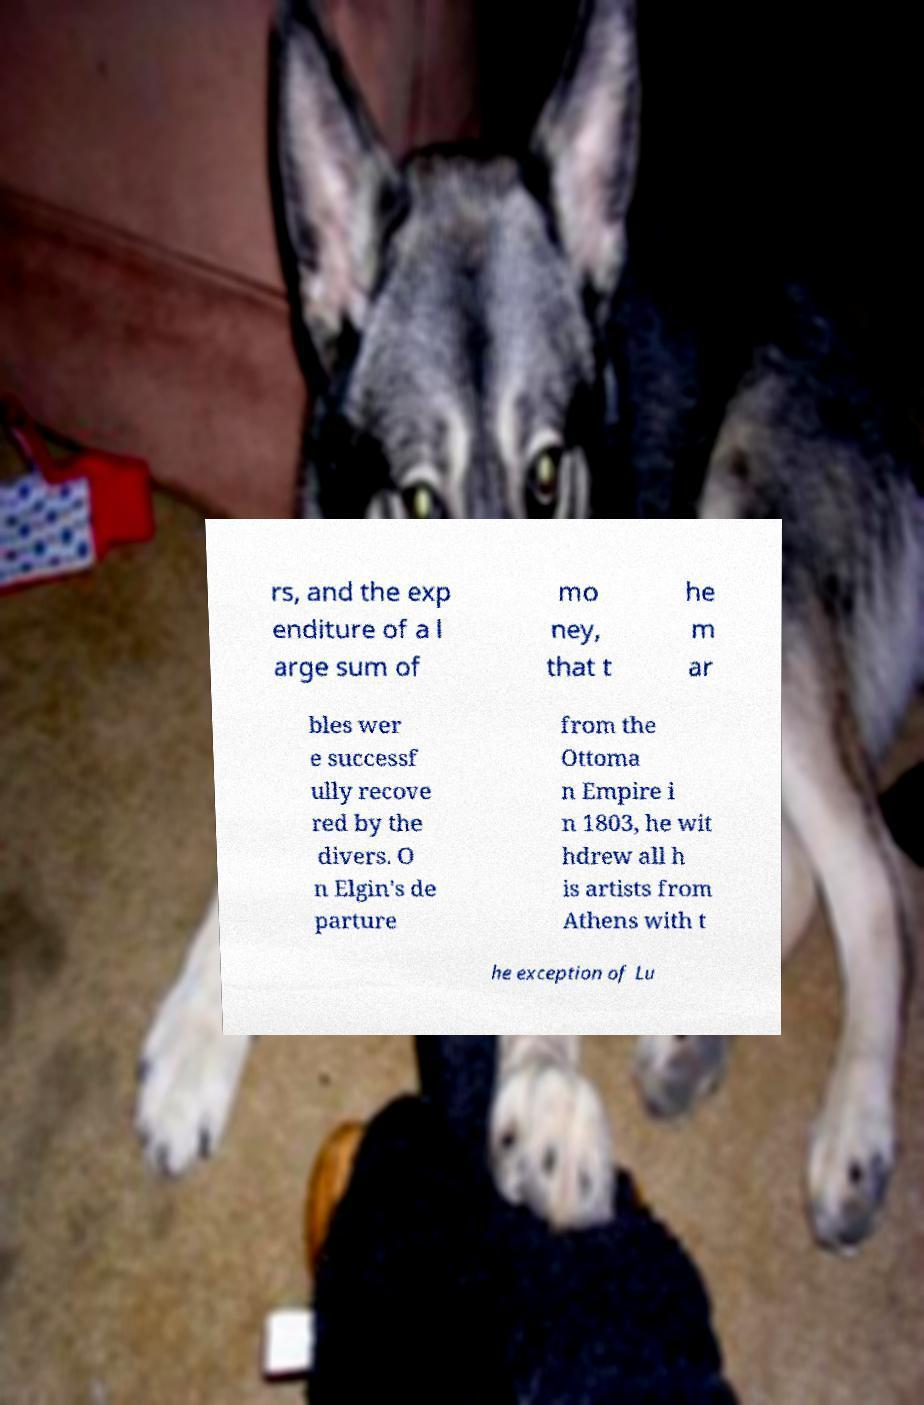For documentation purposes, I need the text within this image transcribed. Could you provide that? rs, and the exp enditure of a l arge sum of mo ney, that t he m ar bles wer e successf ully recove red by the divers. O n Elgin's de parture from the Ottoma n Empire i n 1803, he wit hdrew all h is artists from Athens with t he exception of Lu 